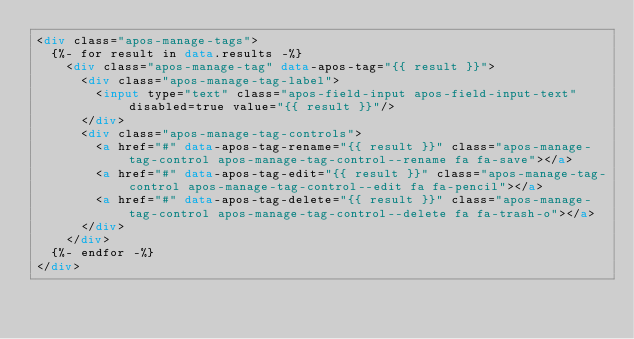Convert code to text. <code><loc_0><loc_0><loc_500><loc_500><_HTML_><div class="apos-manage-tags">
  {%- for result in data.results -%}
    <div class="apos-manage-tag" data-apos-tag="{{ result }}">
      <div class="apos-manage-tag-label">
        <input type="text" class="apos-field-input apos-field-input-text" disabled=true value="{{ result }}"/>
      </div>
      <div class="apos-manage-tag-controls">
        <a href="#" data-apos-tag-rename="{{ result }}" class="apos-manage-tag-control apos-manage-tag-control--rename fa fa-save"></a>
        <a href="#" data-apos-tag-edit="{{ result }}" class="apos-manage-tag-control apos-manage-tag-control--edit fa fa-pencil"></a>
        <a href="#" data-apos-tag-delete="{{ result }}" class="apos-manage-tag-control apos-manage-tag-control--delete fa fa-trash-o"></a>
      </div>
    </div>
  {%- endfor -%}
</div>
</code> 